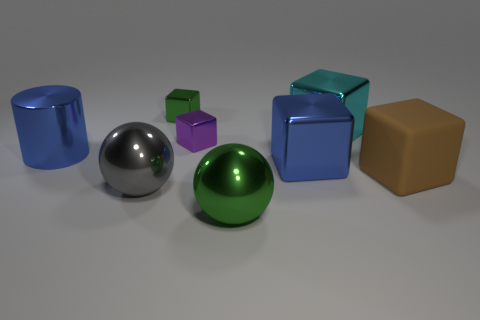There is a small metallic block behind the big cyan thing; is it the same color as the sphere that is on the right side of the small green thing?
Your answer should be compact. Yes. What shape is the object that is both to the right of the large blue metallic cube and left of the brown block?
Keep it short and to the point. Cube. There is a metallic cylinder that is the same size as the brown thing; what is its color?
Your answer should be very brief. Blue. Is there a large metal block of the same color as the metal cylinder?
Provide a short and direct response. Yes. There is a blue metal thing to the right of the large blue cylinder; does it have the same size as the green metal object that is behind the large matte object?
Provide a short and direct response. No. There is a thing that is both in front of the large brown matte block and on the left side of the tiny green shiny thing; what material is it made of?
Your answer should be very brief. Metal. What size is the shiny cube that is the same color as the metal cylinder?
Your answer should be compact. Large. What number of other things are there of the same size as the green ball?
Provide a short and direct response. 5. There is a big blue thing that is to the left of the green cube; what is its material?
Give a very brief answer. Metal. Does the gray object have the same shape as the large rubber object?
Make the answer very short. No. 